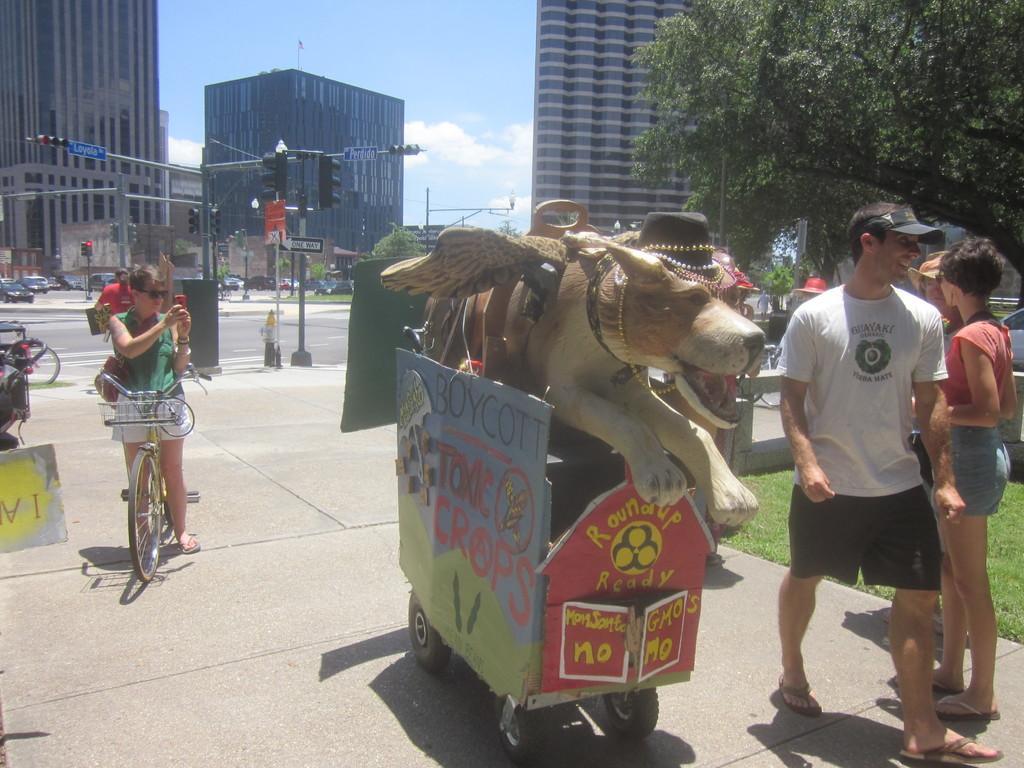In one or two sentences, can you explain what this image depicts? In this picture we can see a group of people where some are at bicycle and some are walking on foot path here we can see a vehicle and dog toy on it and in background we can see buildings, sky with clouds, pole, traffic signal, cars on road, tree. 